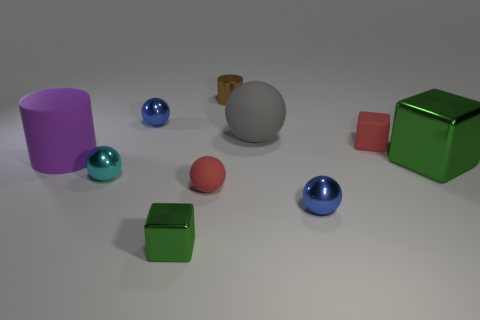There is a blue metal ball behind the purple rubber cylinder; is it the same size as the big shiny thing? The blue metal ball behind the purple rubber cylinder is smaller in size compared to the large sphere at the center of the image, which has a reflective surface that creates highlights and indicates its shiny material. 